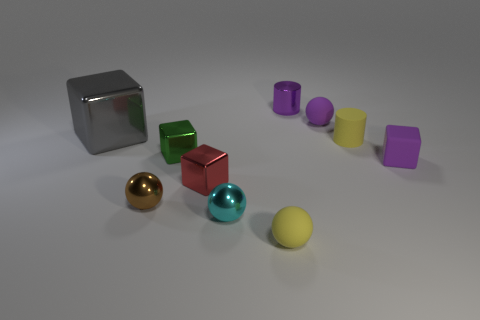Are there any other things that are the same size as the gray cube?
Provide a short and direct response. No. What number of things are yellow rubber cylinders or tiny purple matte objects in front of the tiny purple metal object?
Offer a very short reply. 3. Is the yellow sphere made of the same material as the tiny brown sphere?
Offer a very short reply. No. How many other things are made of the same material as the cyan sphere?
Ensure brevity in your answer.  5. Is the number of big cyan rubber balls greater than the number of metal things?
Keep it short and to the point. No. Is the shape of the tiny object that is in front of the cyan metallic thing the same as  the red metal object?
Offer a terse response. No. Is the number of small brown things less than the number of tiny purple matte things?
Your answer should be compact. Yes. There is a yellow cylinder that is the same size as the purple matte block; what is it made of?
Give a very brief answer. Rubber. There is a tiny rubber cube; is it the same color as the small shiny thing that is behind the rubber cylinder?
Ensure brevity in your answer.  Yes. Is the number of small matte cylinders behind the small yellow matte cylinder less than the number of brown cubes?
Make the answer very short. No. 